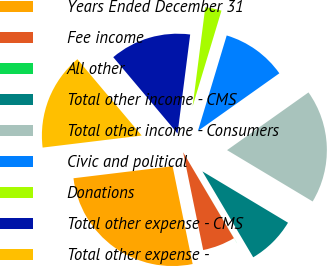Convert chart to OTSL. <chart><loc_0><loc_0><loc_500><loc_500><pie_chart><fcel>Years Ended December 31<fcel>Fee income<fcel>All other<fcel>Total other income - CMS<fcel>Total other income - Consumers<fcel>Civic and political<fcel>Donations<fcel>Total other expense - CMS<fcel>Total other expense -<nl><fcel>26.3%<fcel>5.27%<fcel>0.01%<fcel>7.9%<fcel>18.41%<fcel>10.53%<fcel>2.64%<fcel>13.16%<fcel>15.78%<nl></chart> 